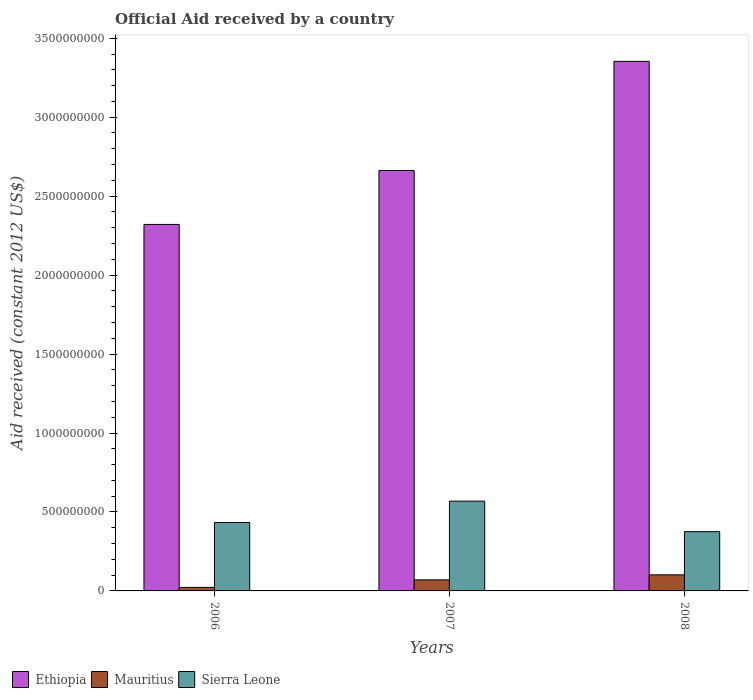How many different coloured bars are there?
Your answer should be compact. 3. How many groups of bars are there?
Your answer should be very brief. 3. Are the number of bars on each tick of the X-axis equal?
Your response must be concise. Yes. How many bars are there on the 2nd tick from the left?
Make the answer very short. 3. What is the net official aid received in Sierra Leone in 2008?
Your answer should be compact. 3.75e+08. Across all years, what is the maximum net official aid received in Mauritius?
Your answer should be compact. 1.02e+08. Across all years, what is the minimum net official aid received in Ethiopia?
Provide a short and direct response. 2.32e+09. In which year was the net official aid received in Sierra Leone maximum?
Give a very brief answer. 2007. What is the total net official aid received in Ethiopia in the graph?
Offer a very short reply. 8.34e+09. What is the difference between the net official aid received in Ethiopia in 2006 and that in 2008?
Your answer should be compact. -1.03e+09. What is the difference between the net official aid received in Sierra Leone in 2008 and the net official aid received in Mauritius in 2006?
Provide a succinct answer. 3.53e+08. What is the average net official aid received in Ethiopia per year?
Provide a succinct answer. 2.78e+09. In the year 2007, what is the difference between the net official aid received in Sierra Leone and net official aid received in Mauritius?
Provide a short and direct response. 4.98e+08. In how many years, is the net official aid received in Sierra Leone greater than 700000000 US$?
Provide a short and direct response. 0. What is the ratio of the net official aid received in Mauritius in 2006 to that in 2008?
Offer a terse response. 0.22. Is the difference between the net official aid received in Sierra Leone in 2006 and 2008 greater than the difference between the net official aid received in Mauritius in 2006 and 2008?
Offer a terse response. Yes. What is the difference between the highest and the second highest net official aid received in Ethiopia?
Your answer should be very brief. 6.91e+08. What is the difference between the highest and the lowest net official aid received in Mauritius?
Offer a terse response. 7.94e+07. Is the sum of the net official aid received in Mauritius in 2006 and 2008 greater than the maximum net official aid received in Sierra Leone across all years?
Your answer should be very brief. No. What does the 3rd bar from the left in 2007 represents?
Provide a short and direct response. Sierra Leone. What does the 1st bar from the right in 2008 represents?
Offer a terse response. Sierra Leone. Is it the case that in every year, the sum of the net official aid received in Ethiopia and net official aid received in Mauritius is greater than the net official aid received in Sierra Leone?
Offer a very short reply. Yes. Are all the bars in the graph horizontal?
Your answer should be very brief. No. How many years are there in the graph?
Your answer should be very brief. 3. What is the difference between two consecutive major ticks on the Y-axis?
Keep it short and to the point. 5.00e+08. Does the graph contain any zero values?
Your response must be concise. No. Does the graph contain grids?
Offer a very short reply. No. Where does the legend appear in the graph?
Your answer should be very brief. Bottom left. How are the legend labels stacked?
Offer a terse response. Horizontal. What is the title of the graph?
Make the answer very short. Official Aid received by a country. What is the label or title of the Y-axis?
Give a very brief answer. Aid received (constant 2012 US$). What is the Aid received (constant 2012 US$) in Ethiopia in 2006?
Your answer should be very brief. 2.32e+09. What is the Aid received (constant 2012 US$) of Mauritius in 2006?
Your response must be concise. 2.24e+07. What is the Aid received (constant 2012 US$) of Sierra Leone in 2006?
Give a very brief answer. 4.33e+08. What is the Aid received (constant 2012 US$) of Ethiopia in 2007?
Your answer should be very brief. 2.66e+09. What is the Aid received (constant 2012 US$) in Mauritius in 2007?
Your response must be concise. 7.01e+07. What is the Aid received (constant 2012 US$) in Sierra Leone in 2007?
Offer a very short reply. 5.69e+08. What is the Aid received (constant 2012 US$) of Ethiopia in 2008?
Give a very brief answer. 3.35e+09. What is the Aid received (constant 2012 US$) in Mauritius in 2008?
Give a very brief answer. 1.02e+08. What is the Aid received (constant 2012 US$) in Sierra Leone in 2008?
Your answer should be compact. 3.75e+08. Across all years, what is the maximum Aid received (constant 2012 US$) of Ethiopia?
Give a very brief answer. 3.35e+09. Across all years, what is the maximum Aid received (constant 2012 US$) of Mauritius?
Provide a short and direct response. 1.02e+08. Across all years, what is the maximum Aid received (constant 2012 US$) of Sierra Leone?
Provide a succinct answer. 5.69e+08. Across all years, what is the minimum Aid received (constant 2012 US$) of Ethiopia?
Provide a succinct answer. 2.32e+09. Across all years, what is the minimum Aid received (constant 2012 US$) of Mauritius?
Provide a short and direct response. 2.24e+07. Across all years, what is the minimum Aid received (constant 2012 US$) in Sierra Leone?
Your answer should be compact. 3.75e+08. What is the total Aid received (constant 2012 US$) of Ethiopia in the graph?
Give a very brief answer. 8.34e+09. What is the total Aid received (constant 2012 US$) in Mauritius in the graph?
Your answer should be compact. 1.94e+08. What is the total Aid received (constant 2012 US$) of Sierra Leone in the graph?
Provide a short and direct response. 1.38e+09. What is the difference between the Aid received (constant 2012 US$) in Ethiopia in 2006 and that in 2007?
Keep it short and to the point. -3.42e+08. What is the difference between the Aid received (constant 2012 US$) in Mauritius in 2006 and that in 2007?
Your response must be concise. -4.77e+07. What is the difference between the Aid received (constant 2012 US$) in Sierra Leone in 2006 and that in 2007?
Make the answer very short. -1.35e+08. What is the difference between the Aid received (constant 2012 US$) of Ethiopia in 2006 and that in 2008?
Provide a succinct answer. -1.03e+09. What is the difference between the Aid received (constant 2012 US$) in Mauritius in 2006 and that in 2008?
Make the answer very short. -7.94e+07. What is the difference between the Aid received (constant 2012 US$) of Sierra Leone in 2006 and that in 2008?
Your response must be concise. 5.80e+07. What is the difference between the Aid received (constant 2012 US$) in Ethiopia in 2007 and that in 2008?
Keep it short and to the point. -6.91e+08. What is the difference between the Aid received (constant 2012 US$) of Mauritius in 2007 and that in 2008?
Provide a succinct answer. -3.18e+07. What is the difference between the Aid received (constant 2012 US$) in Sierra Leone in 2007 and that in 2008?
Give a very brief answer. 1.93e+08. What is the difference between the Aid received (constant 2012 US$) of Ethiopia in 2006 and the Aid received (constant 2012 US$) of Mauritius in 2007?
Keep it short and to the point. 2.25e+09. What is the difference between the Aid received (constant 2012 US$) of Ethiopia in 2006 and the Aid received (constant 2012 US$) of Sierra Leone in 2007?
Your answer should be very brief. 1.75e+09. What is the difference between the Aid received (constant 2012 US$) of Mauritius in 2006 and the Aid received (constant 2012 US$) of Sierra Leone in 2007?
Keep it short and to the point. -5.46e+08. What is the difference between the Aid received (constant 2012 US$) in Ethiopia in 2006 and the Aid received (constant 2012 US$) in Mauritius in 2008?
Ensure brevity in your answer.  2.22e+09. What is the difference between the Aid received (constant 2012 US$) in Ethiopia in 2006 and the Aid received (constant 2012 US$) in Sierra Leone in 2008?
Give a very brief answer. 1.95e+09. What is the difference between the Aid received (constant 2012 US$) in Mauritius in 2006 and the Aid received (constant 2012 US$) in Sierra Leone in 2008?
Offer a terse response. -3.53e+08. What is the difference between the Aid received (constant 2012 US$) in Ethiopia in 2007 and the Aid received (constant 2012 US$) in Mauritius in 2008?
Give a very brief answer. 2.56e+09. What is the difference between the Aid received (constant 2012 US$) of Ethiopia in 2007 and the Aid received (constant 2012 US$) of Sierra Leone in 2008?
Provide a succinct answer. 2.29e+09. What is the difference between the Aid received (constant 2012 US$) of Mauritius in 2007 and the Aid received (constant 2012 US$) of Sierra Leone in 2008?
Make the answer very short. -3.05e+08. What is the average Aid received (constant 2012 US$) in Ethiopia per year?
Your response must be concise. 2.78e+09. What is the average Aid received (constant 2012 US$) in Mauritius per year?
Offer a terse response. 6.48e+07. What is the average Aid received (constant 2012 US$) in Sierra Leone per year?
Keep it short and to the point. 4.59e+08. In the year 2006, what is the difference between the Aid received (constant 2012 US$) in Ethiopia and Aid received (constant 2012 US$) in Mauritius?
Provide a succinct answer. 2.30e+09. In the year 2006, what is the difference between the Aid received (constant 2012 US$) of Ethiopia and Aid received (constant 2012 US$) of Sierra Leone?
Give a very brief answer. 1.89e+09. In the year 2006, what is the difference between the Aid received (constant 2012 US$) in Mauritius and Aid received (constant 2012 US$) in Sierra Leone?
Offer a very short reply. -4.11e+08. In the year 2007, what is the difference between the Aid received (constant 2012 US$) in Ethiopia and Aid received (constant 2012 US$) in Mauritius?
Keep it short and to the point. 2.59e+09. In the year 2007, what is the difference between the Aid received (constant 2012 US$) of Ethiopia and Aid received (constant 2012 US$) of Sierra Leone?
Your response must be concise. 2.09e+09. In the year 2007, what is the difference between the Aid received (constant 2012 US$) of Mauritius and Aid received (constant 2012 US$) of Sierra Leone?
Offer a terse response. -4.98e+08. In the year 2008, what is the difference between the Aid received (constant 2012 US$) in Ethiopia and Aid received (constant 2012 US$) in Mauritius?
Ensure brevity in your answer.  3.25e+09. In the year 2008, what is the difference between the Aid received (constant 2012 US$) in Ethiopia and Aid received (constant 2012 US$) in Sierra Leone?
Ensure brevity in your answer.  2.98e+09. In the year 2008, what is the difference between the Aid received (constant 2012 US$) in Mauritius and Aid received (constant 2012 US$) in Sierra Leone?
Your answer should be compact. -2.73e+08. What is the ratio of the Aid received (constant 2012 US$) of Ethiopia in 2006 to that in 2007?
Provide a short and direct response. 0.87. What is the ratio of the Aid received (constant 2012 US$) in Mauritius in 2006 to that in 2007?
Your answer should be very brief. 0.32. What is the ratio of the Aid received (constant 2012 US$) in Sierra Leone in 2006 to that in 2007?
Your answer should be very brief. 0.76. What is the ratio of the Aid received (constant 2012 US$) in Ethiopia in 2006 to that in 2008?
Provide a succinct answer. 0.69. What is the ratio of the Aid received (constant 2012 US$) in Mauritius in 2006 to that in 2008?
Offer a very short reply. 0.22. What is the ratio of the Aid received (constant 2012 US$) of Sierra Leone in 2006 to that in 2008?
Provide a short and direct response. 1.15. What is the ratio of the Aid received (constant 2012 US$) of Ethiopia in 2007 to that in 2008?
Offer a terse response. 0.79. What is the ratio of the Aid received (constant 2012 US$) of Mauritius in 2007 to that in 2008?
Make the answer very short. 0.69. What is the ratio of the Aid received (constant 2012 US$) of Sierra Leone in 2007 to that in 2008?
Your answer should be very brief. 1.51. What is the difference between the highest and the second highest Aid received (constant 2012 US$) in Ethiopia?
Provide a succinct answer. 6.91e+08. What is the difference between the highest and the second highest Aid received (constant 2012 US$) of Mauritius?
Offer a very short reply. 3.18e+07. What is the difference between the highest and the second highest Aid received (constant 2012 US$) in Sierra Leone?
Your answer should be compact. 1.35e+08. What is the difference between the highest and the lowest Aid received (constant 2012 US$) in Ethiopia?
Ensure brevity in your answer.  1.03e+09. What is the difference between the highest and the lowest Aid received (constant 2012 US$) in Mauritius?
Provide a succinct answer. 7.94e+07. What is the difference between the highest and the lowest Aid received (constant 2012 US$) in Sierra Leone?
Ensure brevity in your answer.  1.93e+08. 